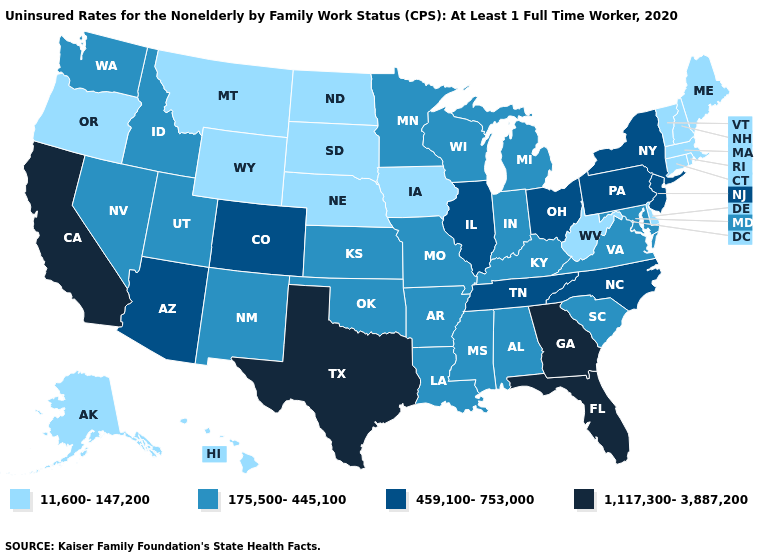What is the value of Tennessee?
Answer briefly. 459,100-753,000. Name the states that have a value in the range 1,117,300-3,887,200?
Short answer required. California, Florida, Georgia, Texas. Does Ohio have a lower value than Texas?
Concise answer only. Yes. Name the states that have a value in the range 11,600-147,200?
Quick response, please. Alaska, Connecticut, Delaware, Hawaii, Iowa, Maine, Massachusetts, Montana, Nebraska, New Hampshire, North Dakota, Oregon, Rhode Island, South Dakota, Vermont, West Virginia, Wyoming. What is the value of California?
Write a very short answer. 1,117,300-3,887,200. Does Connecticut have the highest value in the USA?
Give a very brief answer. No. Does Utah have a lower value than Minnesota?
Write a very short answer. No. Which states have the lowest value in the USA?
Answer briefly. Alaska, Connecticut, Delaware, Hawaii, Iowa, Maine, Massachusetts, Montana, Nebraska, New Hampshire, North Dakota, Oregon, Rhode Island, South Dakota, Vermont, West Virginia, Wyoming. What is the value of Minnesota?
Be succinct. 175,500-445,100. Name the states that have a value in the range 1,117,300-3,887,200?
Be succinct. California, Florida, Georgia, Texas. Name the states that have a value in the range 11,600-147,200?
Answer briefly. Alaska, Connecticut, Delaware, Hawaii, Iowa, Maine, Massachusetts, Montana, Nebraska, New Hampshire, North Dakota, Oregon, Rhode Island, South Dakota, Vermont, West Virginia, Wyoming. Name the states that have a value in the range 1,117,300-3,887,200?
Answer briefly. California, Florida, Georgia, Texas. What is the value of North Dakota?
Write a very short answer. 11,600-147,200. Does Iowa have the same value as Nebraska?
Give a very brief answer. Yes. Does Alabama have the same value as Wyoming?
Be succinct. No. 